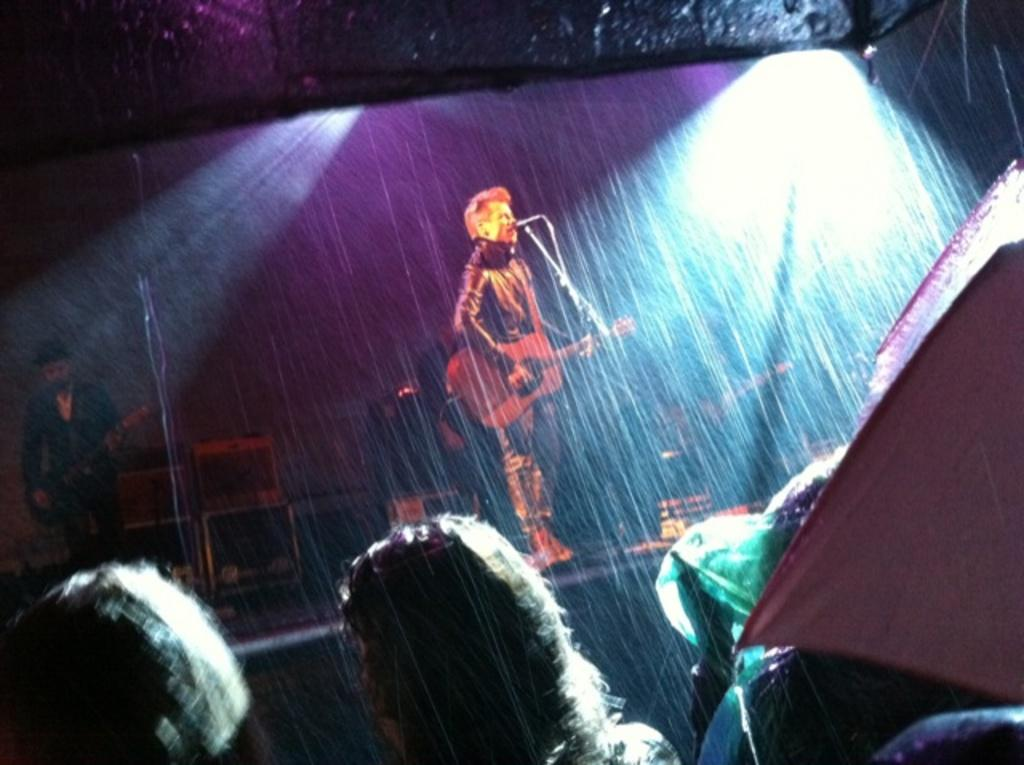How many people are performing in the image? There are two persons performing in the image. What is one person doing while performing? One person is playing a guitar. What is the other person doing while performing? The other person is singing on a microphone. What can be seen in the image besides the performers? There are chairs and other people present in the image. What is the lighting condition in the image? The background of the image is dark. What type of religious ceremony is taking place in the image? There is no indication of a religious ceremony in the image; it features two people performing with a guitar and a microphone. How many knots can be seen in the image? There are no knots visible in the image. 